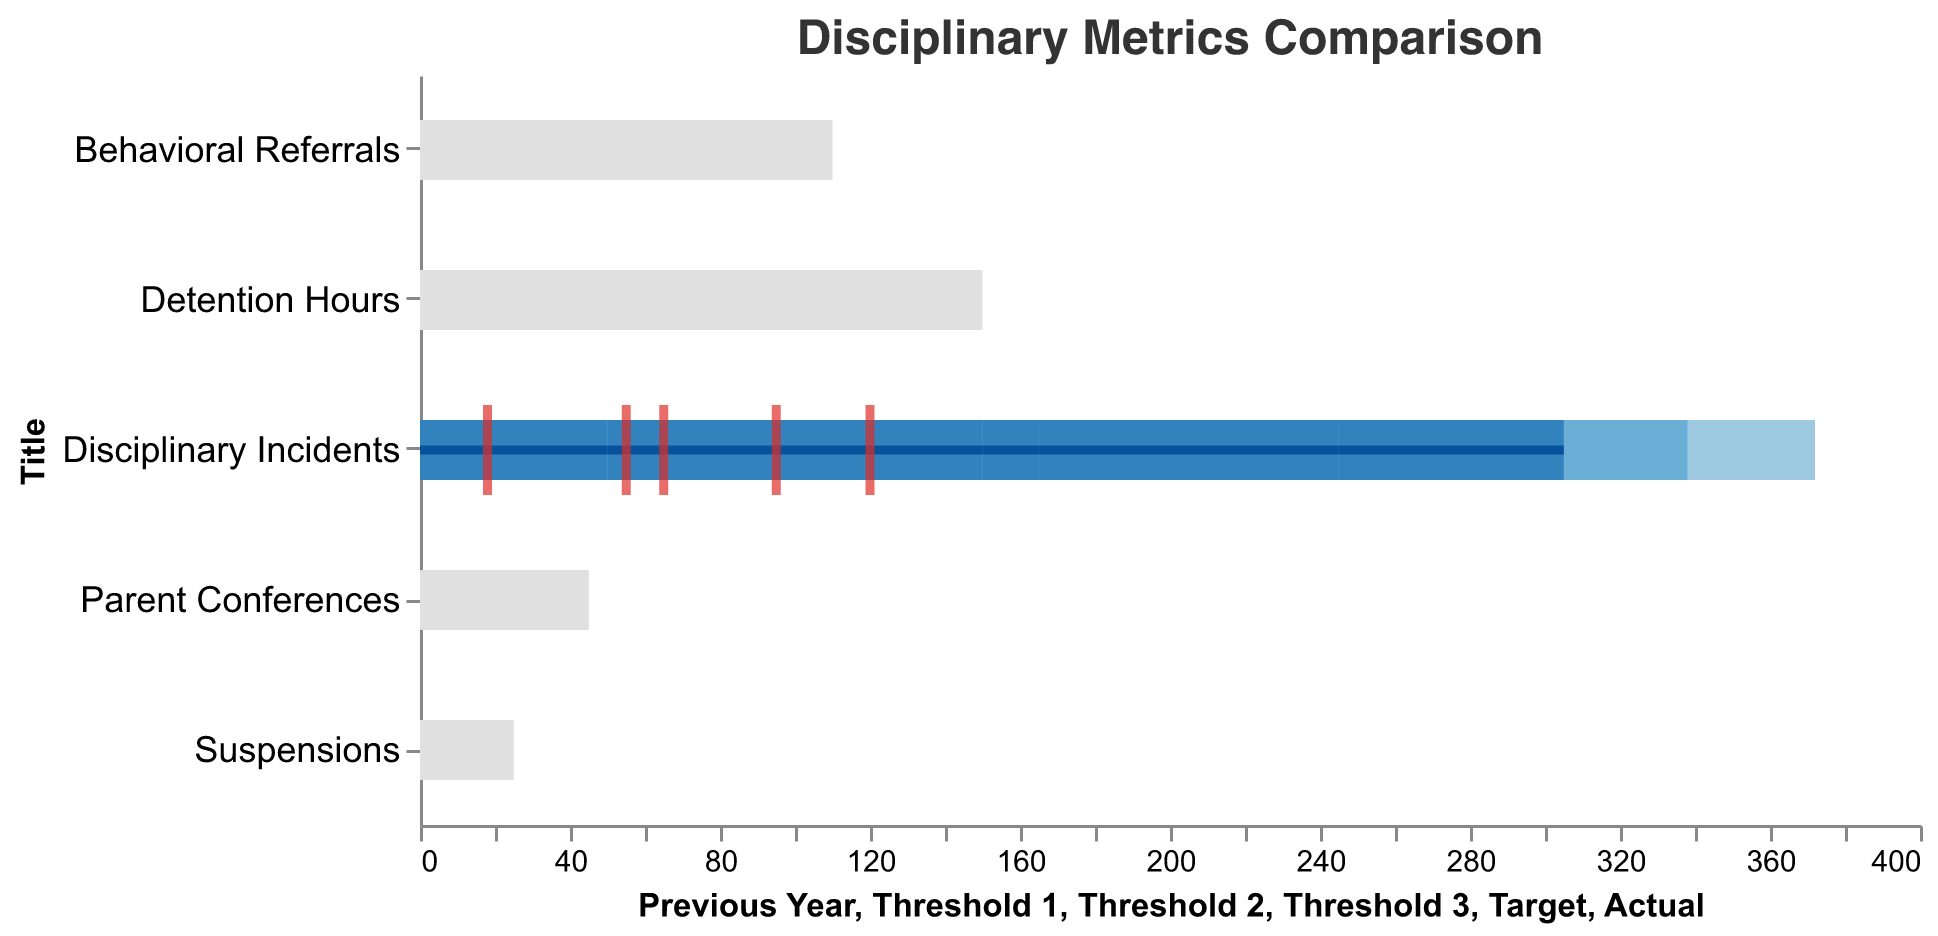what is the title of the plot? The plot's title is found at the top of the figure, and it reads "Disciplinary Metrics Comparison".
Answer: Disciplinary Metrics Comparison What is the 'Actual' value for 'Detention Hours'? The 'Actual' value for 'Detention Hours' is marked with a red tick and is labeled 120 in the plot.
Answer: 120 Which discipline metric had the highest number of incidents last year compared to the current year? To find the answer, compare the 'Previous Year' values for each discipline metric and identify the one with the highest number. 'Detention Hours' had the highest 'Previous Year' value of 150.
Answer: Detention Hours By what percentage did 'Suspensions' decrease from the previous year to the current year? Calculate the percentage decrease using the formula: ((Previous Year - Actual) / Previous Year) * 100. For 'Suspensions', this is ((25 - 18) / 25) * 100 = 28%.
Answer: 28% Which disciplinary metric is performing better than its target this year? Compare the 'Actual' values to the 'Target' values for each discipline metric. 'Disciplinary Incidents' (Actual 65, Target 50), 'Detention Hours' (Actual 120, Target 100), 'Suspensions' (Actual 18, Target 15), 'Behavioral Referrals' (Actual 95, Target 80), and 'Parent Conferences' (Actual 55, Target 60). The 'Parent Conferences' is performing better because the Actual (55) is lower than the Target (60).
Answer: Parent Conferences What is the difference between the 'Previous Year' and 'Actual' values for 'Behavioral Referrals'? Subtract the 'Actual' value from the 'Previous Year' value for 'Behavioral Referrals'. 110 - 95 = 15.
Answer: 15 Which metrics have exceeded their 'Threshold 3' values this year? Compare the 'Actual' values with 'Threshold 3' for each metric: 'Disciplinary Incidents' (65 > 50), 'Detention Hours' (120 > 100), 'Suspensions' (18 > 15), 'Behavioral Referrals' (95 > 80), 'Parent Conferences' (55 < 60). All metrics except 'Parent Conferences' have exceeded their 'Threshold 3' values.
Answer: Disciplinary Incidents, Detention Hours, Suspensions, Behavioral Referrals 